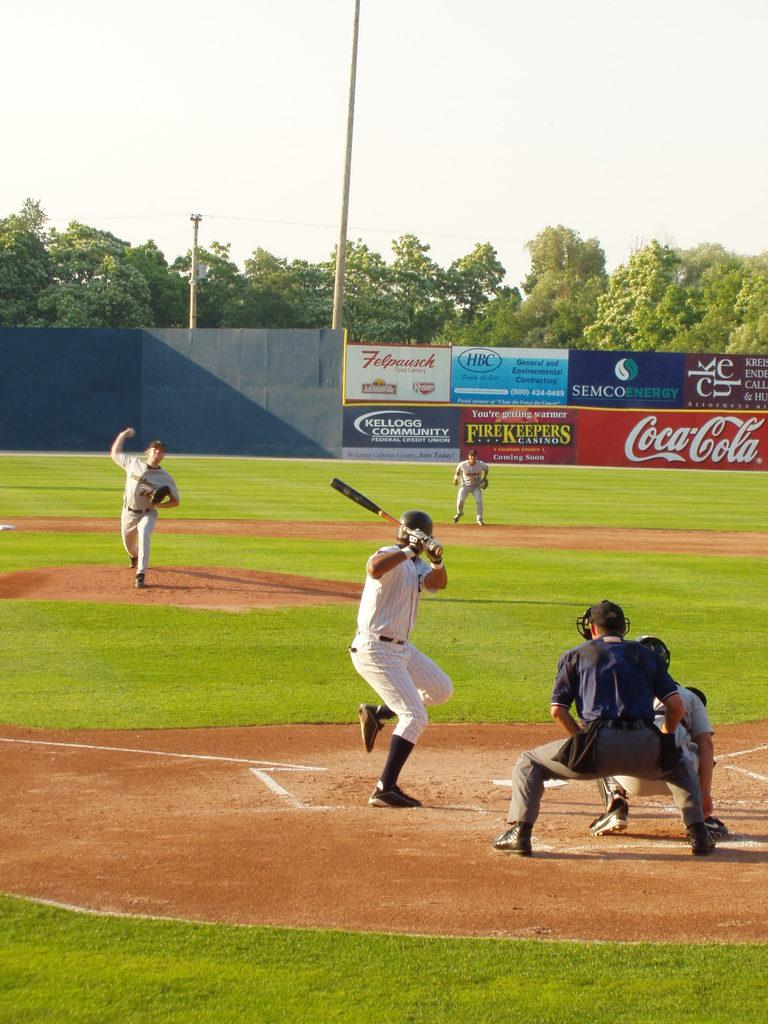<image>
Present a compact description of the photo's key features. Advertisements on a ball field's wall include Coca Cola, FireKeepers Casino, and Semco Energy. 